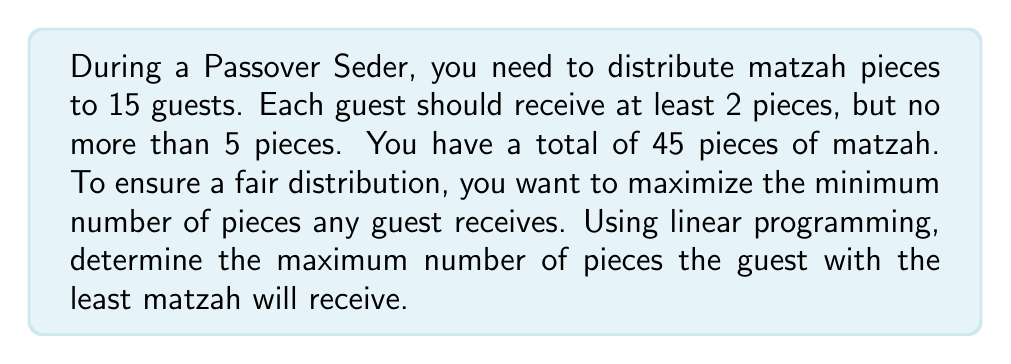What is the answer to this math problem? Let's approach this step-by-step using linear programming:

1) Define variables:
   Let $x$ be the minimum number of pieces any guest receives.

2) Objective function:
   Maximize $x$

3) Constraints:
   a) Each guest receives at least $x$ pieces: $15x \leq 45$
   b) The total number of pieces distributed cannot exceed 45: $15x \leq 45$
   c) Each guest receives at most 5 pieces: $x \leq 5$
   d) Each guest receives at least 2 pieces: $x \geq 2$

4) The linear program:
   $$
   \begin{aligned}
   \text{Maximize } & x \\
   \text{Subject to: } & 15x \leq 45 \\
   & x \leq 5 \\
   & x \geq 2
   \end{aligned}
   $$

5) Solving the linear program:
   - From constraint (a): $x \leq 3$
   - Combining with constraints (c) and (d): $2 \leq x \leq 3$
   - Since we're maximizing $x$, the optimal solution is $x = 3$

6) Verification:
   - With $x = 3$, each guest receives at least 3 pieces
   - Total pieces distributed: $15 * 3 = 45$, which matches the available pieces

Therefore, the maximum number of pieces the guest with the least matzah will receive is 3.
Answer: 3 pieces 